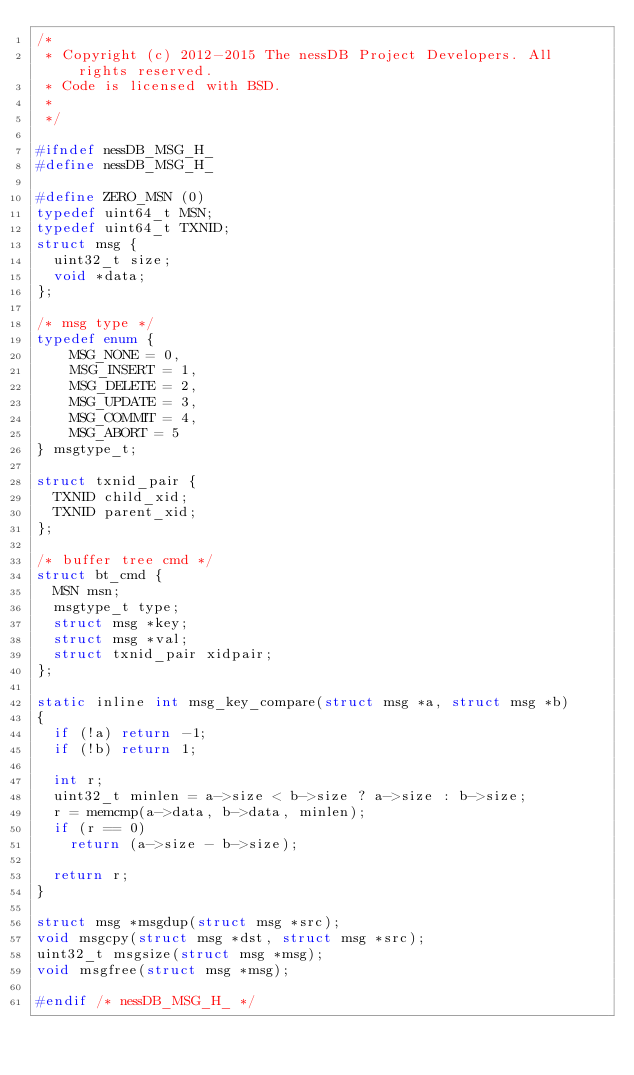Convert code to text. <code><loc_0><loc_0><loc_500><loc_500><_C_>/*
 * Copyright (c) 2012-2015 The nessDB Project Developers. All rights reserved.
 * Code is licensed with BSD.
 *
 */

#ifndef nessDB_MSG_H_
#define nessDB_MSG_H_

#define ZERO_MSN (0)
typedef uint64_t MSN;
typedef uint64_t TXNID;
struct msg {
	uint32_t size;
	void *data;
};

/* msg type */
typedef enum {
    MSG_NONE = 0,
    MSG_INSERT = 1,
    MSG_DELETE = 2,
    MSG_UPDATE = 3,
    MSG_COMMIT = 4,
    MSG_ABORT = 5
} msgtype_t;

struct txnid_pair {
	TXNID child_xid;
	TXNID parent_xid;
};

/* buffer tree cmd */
struct bt_cmd {
	MSN msn;
	msgtype_t type;
	struct msg *key;
	struct msg *val;
	struct txnid_pair xidpair;
};

static inline int msg_key_compare(struct msg *a, struct msg *b)
{
	if (!a) return -1;
	if (!b) return 1;

	int r;
	uint32_t minlen = a->size < b->size ? a->size : b->size;
	r = memcmp(a->data, b->data, minlen);
	if (r == 0)
		return (a->size - b->size);

	return r;
}

struct msg *msgdup(struct msg *src);
void msgcpy(struct msg *dst, struct msg *src);
uint32_t msgsize(struct msg *msg);
void msgfree(struct msg *msg);

#endif /* nessDB_MSG_H_ */
</code> 